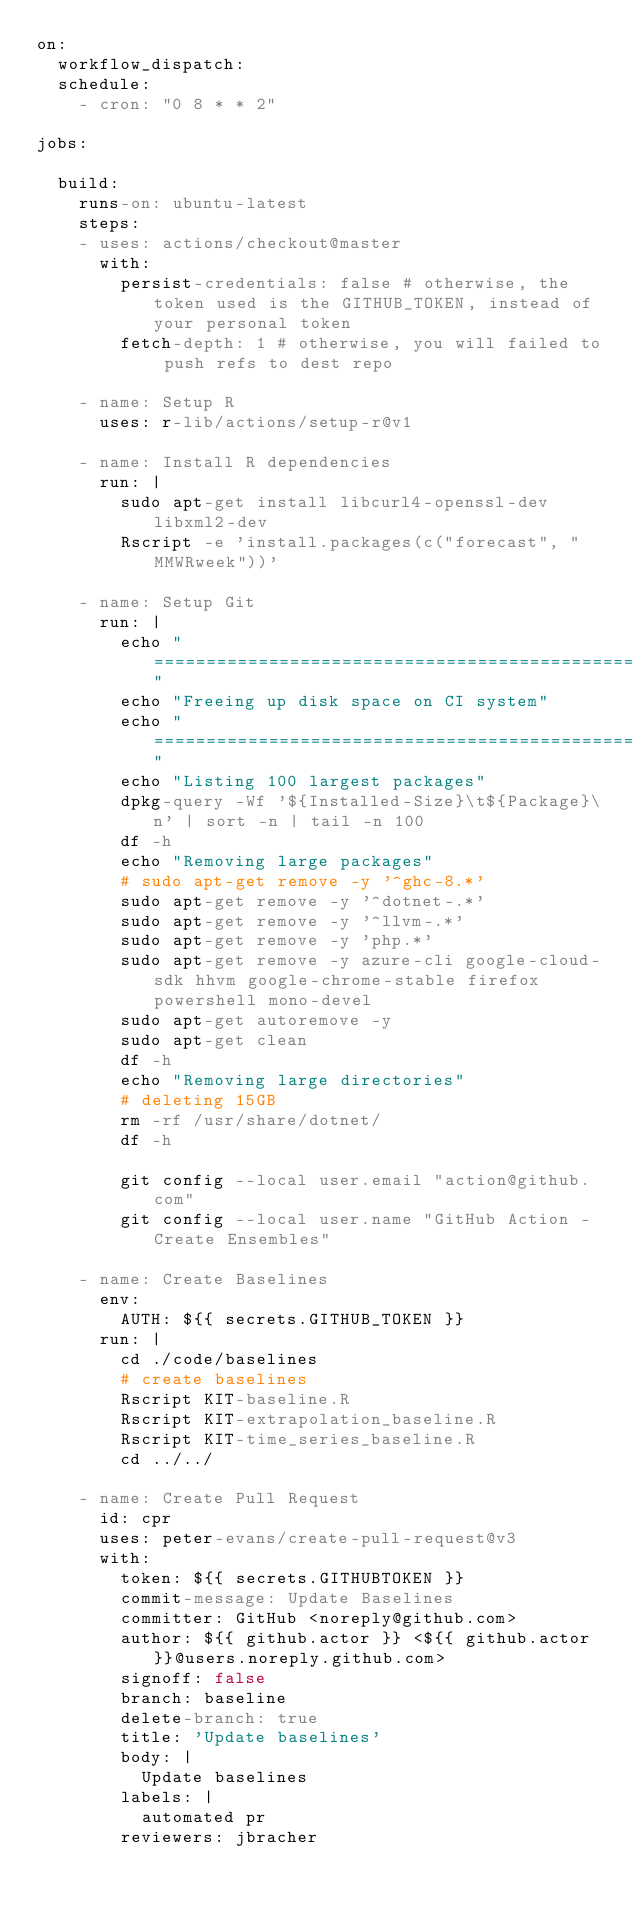Convert code to text. <code><loc_0><loc_0><loc_500><loc_500><_YAML_>on:
  workflow_dispatch:
  schedule:
    - cron: "0 8 * * 2"

jobs:

  build:
    runs-on: ubuntu-latest
    steps:
    - uses: actions/checkout@master
      with:
        persist-credentials: false # otherwise, the token used is the GITHUB_TOKEN, instead of your personal token
        fetch-depth: 1 # otherwise, you will failed to push refs to dest repo

    - name: Setup R
      uses: r-lib/actions/setup-r@v1
      
    - name: Install R dependencies
      run: |
        sudo apt-get install libcurl4-openssl-dev libxml2-dev
        Rscript -e 'install.packages(c("forecast", "MMWRweek"))'

    - name: Setup Git
      run: |
        echo "=============================================================================="
        echo "Freeing up disk space on CI system"
        echo "=============================================================================="
        echo "Listing 100 largest packages"
        dpkg-query -Wf '${Installed-Size}\t${Package}\n' | sort -n | tail -n 100
        df -h
        echo "Removing large packages"
        # sudo apt-get remove -y '^ghc-8.*'
        sudo apt-get remove -y '^dotnet-.*'
        sudo apt-get remove -y '^llvm-.*'
        sudo apt-get remove -y 'php.*'
        sudo apt-get remove -y azure-cli google-cloud-sdk hhvm google-chrome-stable firefox powershell mono-devel
        sudo apt-get autoremove -y
        sudo apt-get clean
        df -h
        echo "Removing large directories"
        # deleting 15GB
        rm -rf /usr/share/dotnet/
        df -h
        
        git config --local user.email "action@github.com"
        git config --local user.name "GitHub Action - Create Ensembles"
    
    - name: Create Baselines
      env:
        AUTH: ${{ secrets.GITHUB_TOKEN }}
      run: | 
        cd ./code/baselines
        # create baselines
        Rscript KIT-baseline.R
        Rscript KIT-extrapolation_baseline.R
        Rscript KIT-time_series_baseline.R
        cd ../../
        
    - name: Create Pull Request
      id: cpr
      uses: peter-evans/create-pull-request@v3
      with:
        token: ${{ secrets.GITHUBTOKEN }}
        commit-message: Update Baselines
        committer: GitHub <noreply@github.com>
        author: ${{ github.actor }} <${{ github.actor }}@users.noreply.github.com>
        signoff: false
        branch: baseline
        delete-branch: true
        title: 'Update baselines'
        body: |
          Update baselines
        labels: |
          automated pr
        reviewers: jbracher
</code> 